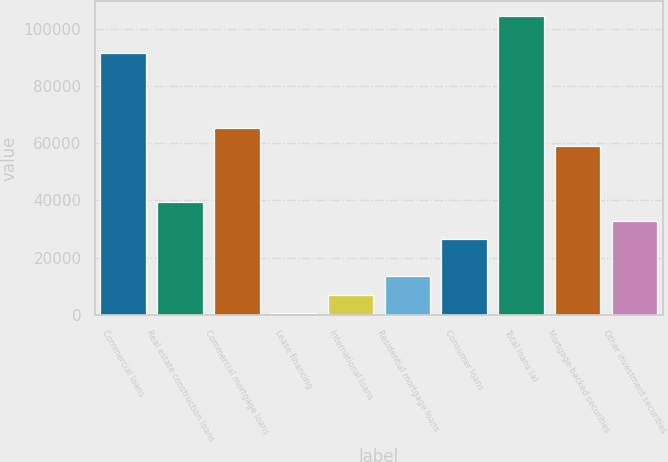Convert chart to OTSL. <chart><loc_0><loc_0><loc_500><loc_500><bar_chart><fcel>Commercial loans<fcel>Real estate construction loans<fcel>Commercial mortgage loans<fcel>Lease financing<fcel>International loans<fcel>Residential mortgage loans<fcel>Consumer loans<fcel>Total loans (a)<fcel>Mortgage-backed securities<fcel>Other investment securities<nl><fcel>91386<fcel>39434<fcel>65410<fcel>470<fcel>6964<fcel>13458<fcel>26446<fcel>104374<fcel>58916<fcel>32940<nl></chart> 